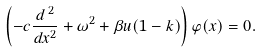Convert formula to latex. <formula><loc_0><loc_0><loc_500><loc_500>\left ( - c \frac { d ^ { \, 2 } } { d x ^ { 2 } } + \omega ^ { 2 } + \beta u ( 1 - k ) \right ) \varphi ( x ) = 0 .</formula> 